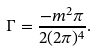Convert formula to latex. <formula><loc_0><loc_0><loc_500><loc_500>\Gamma = \frac { - m ^ { 2 } \pi } { 2 ( 2 \pi ) ^ { 4 } } .</formula> 